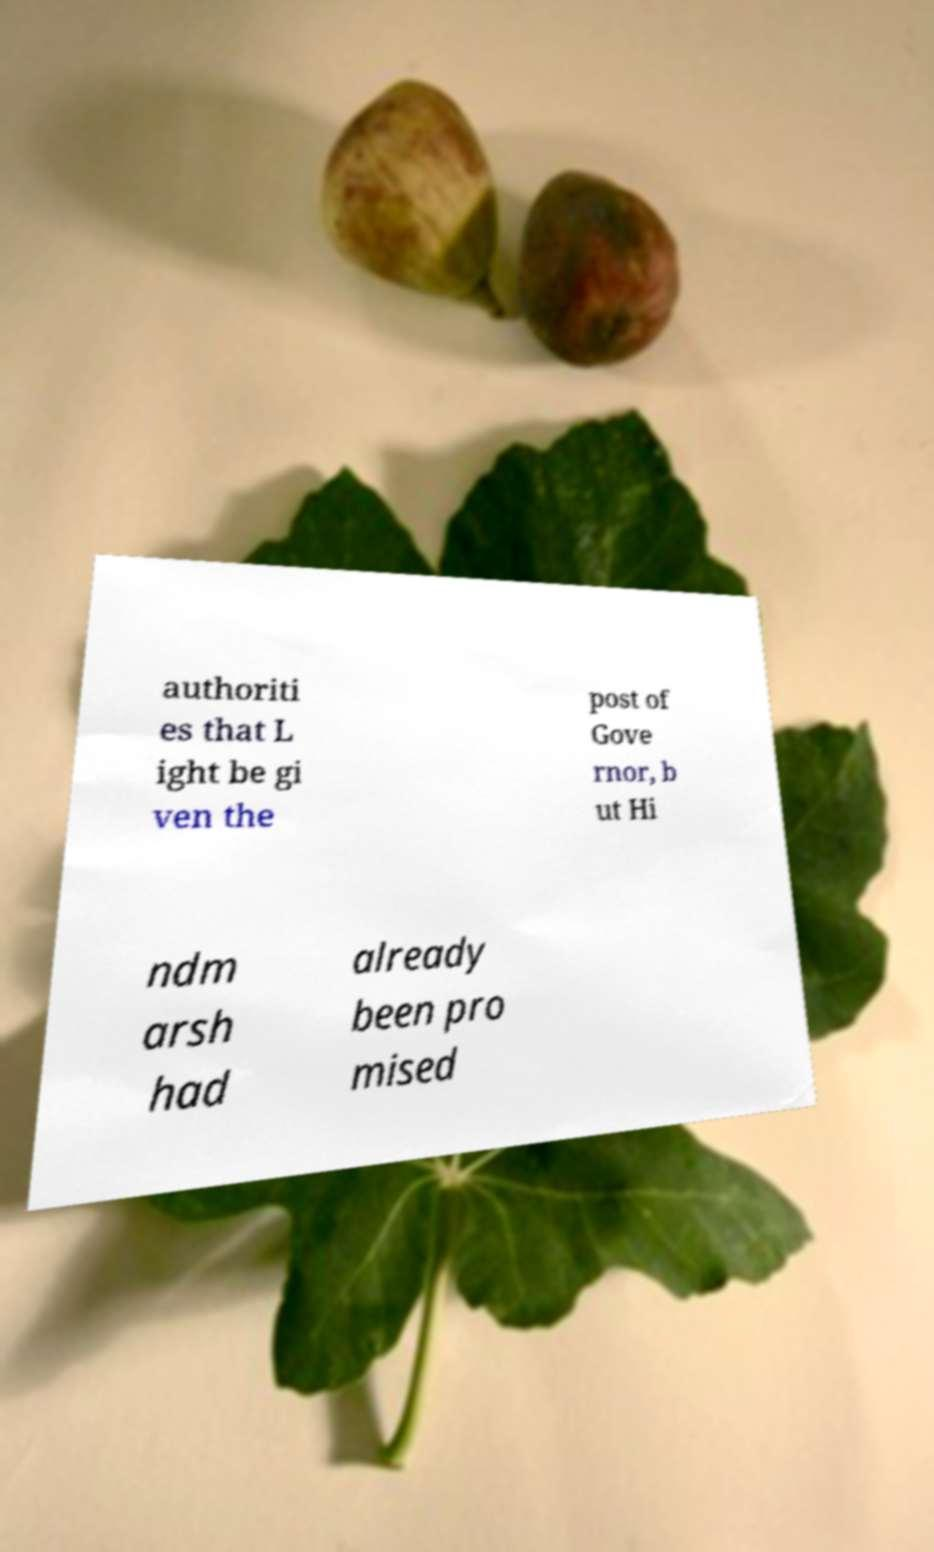Could you extract and type out the text from this image? authoriti es that L ight be gi ven the post of Gove rnor, b ut Hi ndm arsh had already been pro mised 